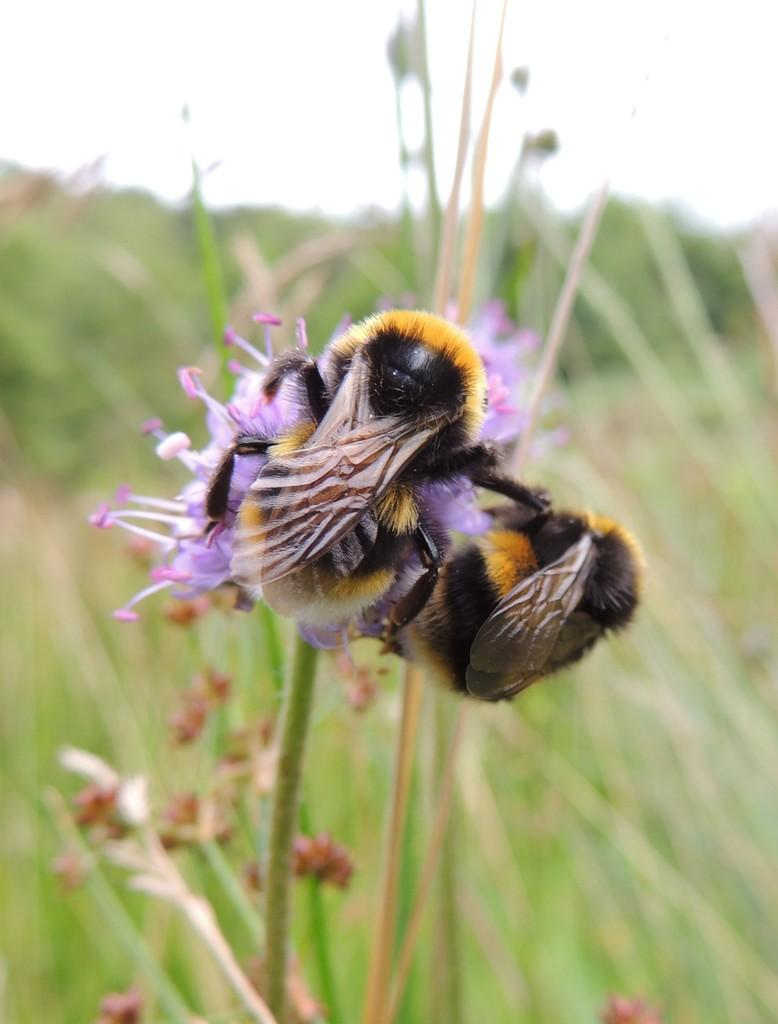What type of insects are present in the image? There are bees in the image. What is the bees potentially attracted to in the image? There is a flower in the image, which might attract the bees. What other types of vegetation are visible in the image? There are plants in the image. What is visible in the background of the image? The sky is visible in the image. How does the land appear in the image? There is no reference to land in the image; it features bees, a flower, and plants. What type of sound can be heard coming from the bees in the image? There is no sound present in the image, as it is a still image. 